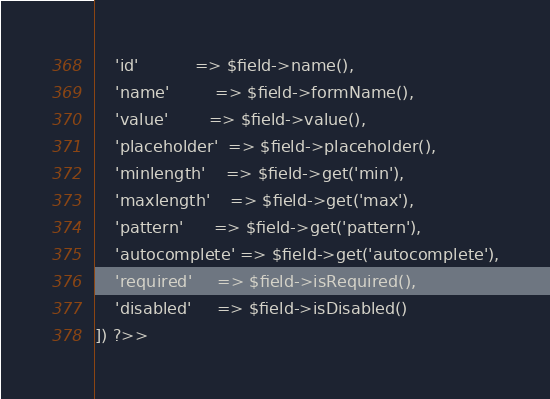<code> <loc_0><loc_0><loc_500><loc_500><_PHP_>    'id'           => $field->name(),
    'name'         => $field->formName(),
    'value'        => $field->value(),
    'placeholder'  => $field->placeholder(),
    'minlength'    => $field->get('min'),
    'maxlength'    => $field->get('max'),
    'pattern'      => $field->get('pattern'),
    'autocomplete' => $field->get('autocomplete'),
    'required'     => $field->isRequired(),
    'disabled'     => $field->isDisabled()
]) ?>>
</code> 